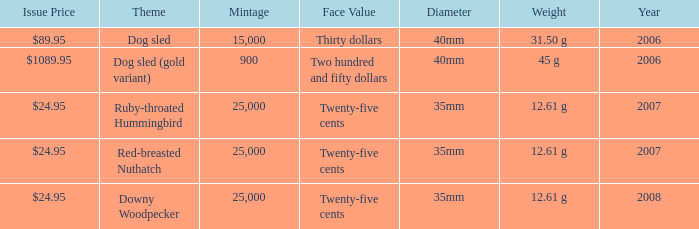What is the Year of the Coin with an Issue Price of $1089.95 and Mintage less than 900? None. 